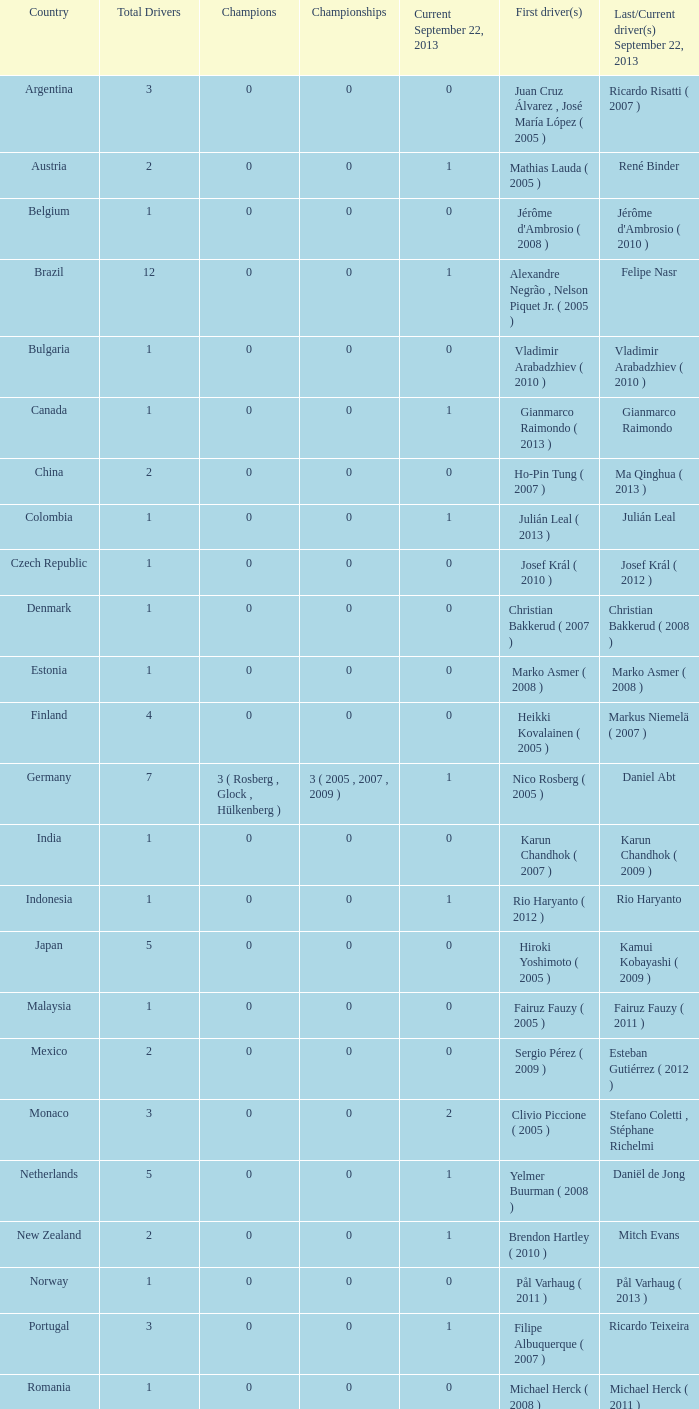How many champions were there when the last driver for September 22, 2013 was vladimir arabadzhiev ( 2010 )? 0.0. I'm looking to parse the entire table for insights. Could you assist me with that? {'header': ['Country', 'Total Drivers', 'Champions', 'Championships', 'Current September 22, 2013', 'First driver(s)', 'Last/Current driver(s) September 22, 2013'], 'rows': [['Argentina', '3', '0', '0', '0', 'Juan Cruz Álvarez , José María López ( 2005 )', 'Ricardo Risatti ( 2007 )'], ['Austria', '2', '0', '0', '1', 'Mathias Lauda ( 2005 )', 'René Binder'], ['Belgium', '1', '0', '0', '0', "Jérôme d'Ambrosio ( 2008 )", "Jérôme d'Ambrosio ( 2010 )"], ['Brazil', '12', '0', '0', '1', 'Alexandre Negrão , Nelson Piquet Jr. ( 2005 )', 'Felipe Nasr'], ['Bulgaria', '1', '0', '0', '0', 'Vladimir Arabadzhiev ( 2010 )', 'Vladimir Arabadzhiev ( 2010 )'], ['Canada', '1', '0', '0', '1', 'Gianmarco Raimondo ( 2013 )', 'Gianmarco Raimondo'], ['China', '2', '0', '0', '0', 'Ho-Pin Tung ( 2007 )', 'Ma Qinghua ( 2013 )'], ['Colombia', '1', '0', '0', '1', 'Julián Leal ( 2013 )', 'Julián Leal'], ['Czech Republic', '1', '0', '0', '0', 'Josef Král ( 2010 )', 'Josef Král ( 2012 )'], ['Denmark', '1', '0', '0', '0', 'Christian Bakkerud ( 2007 )', 'Christian Bakkerud ( 2008 )'], ['Estonia', '1', '0', '0', '0', 'Marko Asmer ( 2008 )', 'Marko Asmer ( 2008 )'], ['Finland', '4', '0', '0', '0', 'Heikki Kovalainen ( 2005 )', 'Markus Niemelä ( 2007 )'], ['Germany', '7', '3 ( Rosberg , Glock , Hülkenberg )', '3 ( 2005 , 2007 , 2009 )', '1', 'Nico Rosberg ( 2005 )', 'Daniel Abt'], ['India', '1', '0', '0', '0', 'Karun Chandhok ( 2007 )', 'Karun Chandhok ( 2009 )'], ['Indonesia', '1', '0', '0', '1', 'Rio Haryanto ( 2012 )', 'Rio Haryanto'], ['Japan', '5', '0', '0', '0', 'Hiroki Yoshimoto ( 2005 )', 'Kamui Kobayashi ( 2009 )'], ['Malaysia', '1', '0', '0', '0', 'Fairuz Fauzy ( 2005 )', 'Fairuz Fauzy ( 2011 )'], ['Mexico', '2', '0', '0', '0', 'Sergio Pérez ( 2009 )', 'Esteban Gutiérrez ( 2012 )'], ['Monaco', '3', '0', '0', '2', 'Clivio Piccione ( 2005 )', 'Stefano Coletti , Stéphane Richelmi'], ['Netherlands', '5', '0', '0', '1', 'Yelmer Buurman ( 2008 )', 'Daniël de Jong'], ['New Zealand', '2', '0', '0', '1', 'Brendon Hartley ( 2010 )', 'Mitch Evans'], ['Norway', '1', '0', '0', '0', 'Pål Varhaug ( 2011 )', 'Pål Varhaug ( 2013 )'], ['Portugal', '3', '0', '0', '1', 'Filipe Albuquerque ( 2007 )', 'Ricardo Teixeira'], ['Romania', '1', '0', '0', '0', 'Michael Herck ( 2008 )', 'Michael Herck ( 2011 )'], ['Russia', '2', '0', '0', '0', 'Vitaly Petrov ( 2006 )', 'Mikhail Aleshin ( 2011 )'], ['Serbia', '1', '0', '0', '0', 'Miloš Pavlović ( 2008 )', 'Miloš Pavlović ( 2008 )'], ['South Africa', '1', '0', '0', '0', 'Adrian Zaugg ( 2007 )', 'Adrian Zaugg ( 2010 )'], ['Spain', '10', '0', '0', '2', 'Borja García , Sergio Hernández ( 2005 )', 'Sergio Canamasas , Dani Clos'], ['Sweden', '1', '0', '0', '1', 'Marcus Ericsson ( 2010 )', 'Marcus Ericsson'], ['Switzerland', '5', '0', '0', '2', 'Neel Jani ( 2005 )', 'Fabio Leimer , Simon Trummer'], ['Turkey', '2', '0', '0', '0', 'Can Artam ( 2005 )', 'Jason Tahincioglu ( 2007 )'], ['United Arab Emirates', '1', '0', '0', '0', 'Andreas Zuber ( 2006 )', 'Andreas Zuber ( 2009 )'], ['United States', '4', '0', '0', '2', 'Scott Speed ( 2005 )', 'Jake Rosenzweig , Alexander Rossi']]} 